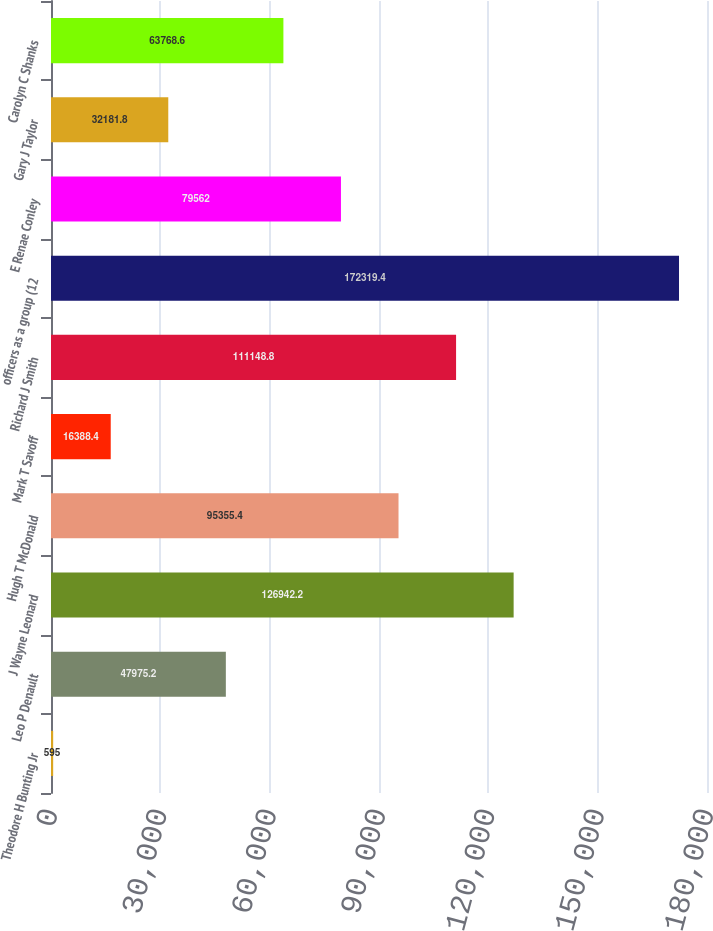Convert chart. <chart><loc_0><loc_0><loc_500><loc_500><bar_chart><fcel>Theodore H Bunting Jr<fcel>Leo P Denault<fcel>J Wayne Leonard<fcel>Hugh T McDonald<fcel>Mark T Savoff<fcel>Richard J Smith<fcel>officers as a group (12<fcel>E Renae Conley<fcel>Gary J Taylor<fcel>Carolyn C Shanks<nl><fcel>595<fcel>47975.2<fcel>126942<fcel>95355.4<fcel>16388.4<fcel>111149<fcel>172319<fcel>79562<fcel>32181.8<fcel>63768.6<nl></chart> 